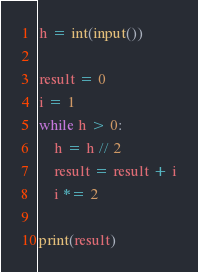Convert code to text. <code><loc_0><loc_0><loc_500><loc_500><_Python_>h = int(input())

result = 0
i = 1
while h > 0:
    h = h // 2
    result = result + i
    i *= 2

print(result)</code> 